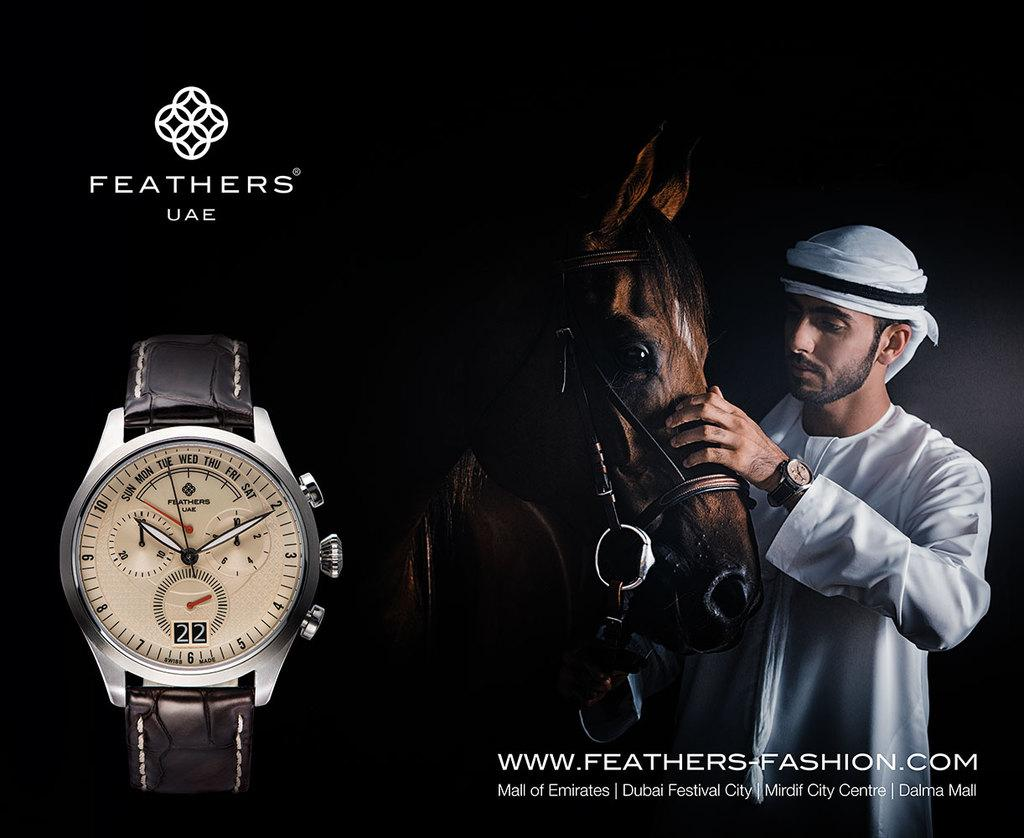<image>
Render a clear and concise summary of the photo. An arab man petting a horse with an advertisement for a watch brand called Feathers UAE. 